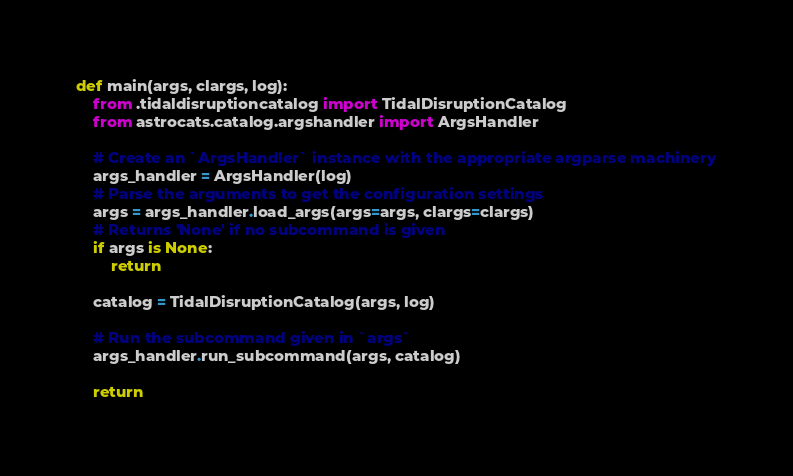<code> <loc_0><loc_0><loc_500><loc_500><_Python_>def main(args, clargs, log):
    from .tidaldisruptioncatalog import TidalDisruptionCatalog
    from astrocats.catalog.argshandler import ArgsHandler

    # Create an `ArgsHandler` instance with the appropriate argparse machinery
    args_handler = ArgsHandler(log)
    # Parse the arguments to get the configuration settings
    args = args_handler.load_args(args=args, clargs=clargs)
    # Returns 'None' if no subcommand is given
    if args is None:
        return

    catalog = TidalDisruptionCatalog(args, log)

    # Run the subcommand given in `args`
    args_handler.run_subcommand(args, catalog)

    return
</code> 